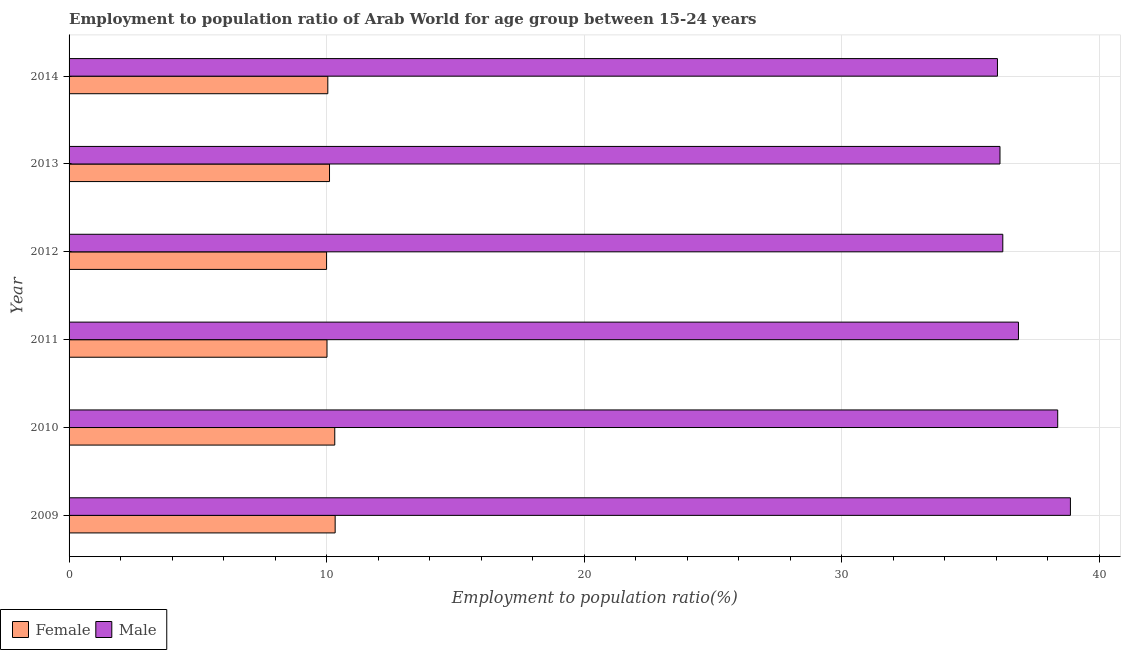How many groups of bars are there?
Provide a short and direct response. 6. Are the number of bars per tick equal to the number of legend labels?
Offer a very short reply. Yes. How many bars are there on the 4th tick from the top?
Your answer should be very brief. 2. How many bars are there on the 4th tick from the bottom?
Provide a succinct answer. 2. What is the label of the 1st group of bars from the top?
Offer a terse response. 2014. What is the employment to population ratio(female) in 2013?
Ensure brevity in your answer.  10.11. Across all years, what is the maximum employment to population ratio(female)?
Make the answer very short. 10.33. Across all years, what is the minimum employment to population ratio(female)?
Ensure brevity in your answer.  10. In which year was the employment to population ratio(female) maximum?
Keep it short and to the point. 2009. What is the total employment to population ratio(female) in the graph?
Keep it short and to the point. 60.83. What is the difference between the employment to population ratio(female) in 2012 and that in 2013?
Your response must be concise. -0.11. What is the difference between the employment to population ratio(female) in 2009 and the employment to population ratio(male) in 2012?
Provide a short and direct response. -25.93. What is the average employment to population ratio(male) per year?
Offer a terse response. 37.1. In the year 2011, what is the difference between the employment to population ratio(female) and employment to population ratio(male)?
Offer a very short reply. -26.85. Is the employment to population ratio(female) in 2011 less than that in 2012?
Provide a succinct answer. No. Is the difference between the employment to population ratio(female) in 2010 and 2011 greater than the difference between the employment to population ratio(male) in 2010 and 2011?
Offer a terse response. No. What is the difference between the highest and the second highest employment to population ratio(male)?
Make the answer very short. 0.49. What is the difference between the highest and the lowest employment to population ratio(male)?
Offer a very short reply. 2.83. In how many years, is the employment to population ratio(female) greater than the average employment to population ratio(female) taken over all years?
Offer a very short reply. 2. Is the sum of the employment to population ratio(female) in 2009 and 2014 greater than the maximum employment to population ratio(male) across all years?
Your response must be concise. No. What does the 1st bar from the top in 2014 represents?
Provide a short and direct response. Male. What does the 2nd bar from the bottom in 2010 represents?
Offer a terse response. Male. Are all the bars in the graph horizontal?
Keep it short and to the point. Yes. How many years are there in the graph?
Offer a terse response. 6. What is the difference between two consecutive major ticks on the X-axis?
Provide a short and direct response. 10. Are the values on the major ticks of X-axis written in scientific E-notation?
Give a very brief answer. No. Does the graph contain grids?
Your answer should be very brief. Yes. How are the legend labels stacked?
Make the answer very short. Horizontal. What is the title of the graph?
Offer a very short reply. Employment to population ratio of Arab World for age group between 15-24 years. Does "Rural Population" appear as one of the legend labels in the graph?
Ensure brevity in your answer.  No. What is the Employment to population ratio(%) in Female in 2009?
Your answer should be compact. 10.33. What is the Employment to population ratio(%) of Male in 2009?
Your answer should be very brief. 38.89. What is the Employment to population ratio(%) of Female in 2010?
Give a very brief answer. 10.32. What is the Employment to population ratio(%) in Male in 2010?
Your answer should be very brief. 38.39. What is the Employment to population ratio(%) of Female in 2011?
Provide a succinct answer. 10.02. What is the Employment to population ratio(%) in Male in 2011?
Ensure brevity in your answer.  36.87. What is the Employment to population ratio(%) in Female in 2012?
Provide a short and direct response. 10. What is the Employment to population ratio(%) in Male in 2012?
Your answer should be compact. 36.26. What is the Employment to population ratio(%) in Female in 2013?
Provide a short and direct response. 10.11. What is the Employment to population ratio(%) in Male in 2013?
Provide a succinct answer. 36.15. What is the Employment to population ratio(%) in Female in 2014?
Provide a succinct answer. 10.05. What is the Employment to population ratio(%) in Male in 2014?
Make the answer very short. 36.05. Across all years, what is the maximum Employment to population ratio(%) of Female?
Provide a succinct answer. 10.33. Across all years, what is the maximum Employment to population ratio(%) in Male?
Offer a terse response. 38.89. Across all years, what is the minimum Employment to population ratio(%) of Female?
Make the answer very short. 10. Across all years, what is the minimum Employment to population ratio(%) of Male?
Keep it short and to the point. 36.05. What is the total Employment to population ratio(%) in Female in the graph?
Your answer should be very brief. 60.83. What is the total Employment to population ratio(%) in Male in the graph?
Offer a terse response. 222.62. What is the difference between the Employment to population ratio(%) in Female in 2009 and that in 2010?
Offer a very short reply. 0.02. What is the difference between the Employment to population ratio(%) of Male in 2009 and that in 2010?
Your answer should be very brief. 0.49. What is the difference between the Employment to population ratio(%) in Female in 2009 and that in 2011?
Your answer should be compact. 0.32. What is the difference between the Employment to population ratio(%) in Male in 2009 and that in 2011?
Your response must be concise. 2.02. What is the difference between the Employment to population ratio(%) in Female in 2009 and that in 2012?
Offer a very short reply. 0.33. What is the difference between the Employment to population ratio(%) of Male in 2009 and that in 2012?
Ensure brevity in your answer.  2.63. What is the difference between the Employment to population ratio(%) in Female in 2009 and that in 2013?
Ensure brevity in your answer.  0.22. What is the difference between the Employment to population ratio(%) of Male in 2009 and that in 2013?
Your response must be concise. 2.74. What is the difference between the Employment to population ratio(%) of Female in 2009 and that in 2014?
Make the answer very short. 0.29. What is the difference between the Employment to population ratio(%) in Male in 2009 and that in 2014?
Offer a terse response. 2.83. What is the difference between the Employment to population ratio(%) of Female in 2010 and that in 2011?
Give a very brief answer. 0.3. What is the difference between the Employment to population ratio(%) in Male in 2010 and that in 2011?
Ensure brevity in your answer.  1.52. What is the difference between the Employment to population ratio(%) in Female in 2010 and that in 2012?
Your answer should be compact. 0.32. What is the difference between the Employment to population ratio(%) in Male in 2010 and that in 2012?
Give a very brief answer. 2.13. What is the difference between the Employment to population ratio(%) of Female in 2010 and that in 2013?
Offer a very short reply. 0.2. What is the difference between the Employment to population ratio(%) in Male in 2010 and that in 2013?
Ensure brevity in your answer.  2.24. What is the difference between the Employment to population ratio(%) of Female in 2010 and that in 2014?
Make the answer very short. 0.27. What is the difference between the Employment to population ratio(%) of Male in 2010 and that in 2014?
Your answer should be very brief. 2.34. What is the difference between the Employment to population ratio(%) of Female in 2011 and that in 2012?
Your answer should be compact. 0.02. What is the difference between the Employment to population ratio(%) in Male in 2011 and that in 2012?
Keep it short and to the point. 0.61. What is the difference between the Employment to population ratio(%) of Female in 2011 and that in 2013?
Give a very brief answer. -0.1. What is the difference between the Employment to population ratio(%) in Male in 2011 and that in 2013?
Offer a very short reply. 0.72. What is the difference between the Employment to population ratio(%) in Female in 2011 and that in 2014?
Your response must be concise. -0.03. What is the difference between the Employment to population ratio(%) of Male in 2011 and that in 2014?
Ensure brevity in your answer.  0.82. What is the difference between the Employment to population ratio(%) in Female in 2012 and that in 2013?
Make the answer very short. -0.11. What is the difference between the Employment to population ratio(%) in Male in 2012 and that in 2013?
Keep it short and to the point. 0.11. What is the difference between the Employment to population ratio(%) of Female in 2012 and that in 2014?
Give a very brief answer. -0.05. What is the difference between the Employment to population ratio(%) of Male in 2012 and that in 2014?
Your answer should be compact. 0.21. What is the difference between the Employment to population ratio(%) in Female in 2013 and that in 2014?
Keep it short and to the point. 0.07. What is the difference between the Employment to population ratio(%) in Male in 2013 and that in 2014?
Offer a terse response. 0.1. What is the difference between the Employment to population ratio(%) of Female in 2009 and the Employment to population ratio(%) of Male in 2010?
Provide a short and direct response. -28.06. What is the difference between the Employment to population ratio(%) of Female in 2009 and the Employment to population ratio(%) of Male in 2011?
Your answer should be compact. -26.54. What is the difference between the Employment to population ratio(%) in Female in 2009 and the Employment to population ratio(%) in Male in 2012?
Your answer should be very brief. -25.93. What is the difference between the Employment to population ratio(%) of Female in 2009 and the Employment to population ratio(%) of Male in 2013?
Keep it short and to the point. -25.82. What is the difference between the Employment to population ratio(%) of Female in 2009 and the Employment to population ratio(%) of Male in 2014?
Make the answer very short. -25.72. What is the difference between the Employment to population ratio(%) in Female in 2010 and the Employment to population ratio(%) in Male in 2011?
Your response must be concise. -26.55. What is the difference between the Employment to population ratio(%) in Female in 2010 and the Employment to population ratio(%) in Male in 2012?
Your answer should be compact. -25.94. What is the difference between the Employment to population ratio(%) in Female in 2010 and the Employment to population ratio(%) in Male in 2013?
Your answer should be very brief. -25.83. What is the difference between the Employment to population ratio(%) in Female in 2010 and the Employment to population ratio(%) in Male in 2014?
Your answer should be very brief. -25.74. What is the difference between the Employment to population ratio(%) of Female in 2011 and the Employment to population ratio(%) of Male in 2012?
Your answer should be very brief. -26.24. What is the difference between the Employment to population ratio(%) in Female in 2011 and the Employment to population ratio(%) in Male in 2013?
Provide a succinct answer. -26.14. What is the difference between the Employment to population ratio(%) in Female in 2011 and the Employment to population ratio(%) in Male in 2014?
Offer a terse response. -26.04. What is the difference between the Employment to population ratio(%) of Female in 2012 and the Employment to population ratio(%) of Male in 2013?
Your answer should be compact. -26.15. What is the difference between the Employment to population ratio(%) of Female in 2012 and the Employment to population ratio(%) of Male in 2014?
Offer a terse response. -26.05. What is the difference between the Employment to population ratio(%) in Female in 2013 and the Employment to population ratio(%) in Male in 2014?
Provide a succinct answer. -25.94. What is the average Employment to population ratio(%) in Female per year?
Offer a very short reply. 10.14. What is the average Employment to population ratio(%) in Male per year?
Your answer should be very brief. 37.1. In the year 2009, what is the difference between the Employment to population ratio(%) in Female and Employment to population ratio(%) in Male?
Offer a very short reply. -28.55. In the year 2010, what is the difference between the Employment to population ratio(%) in Female and Employment to population ratio(%) in Male?
Your answer should be compact. -28.08. In the year 2011, what is the difference between the Employment to population ratio(%) of Female and Employment to population ratio(%) of Male?
Your answer should be very brief. -26.85. In the year 2012, what is the difference between the Employment to population ratio(%) in Female and Employment to population ratio(%) in Male?
Provide a short and direct response. -26.26. In the year 2013, what is the difference between the Employment to population ratio(%) of Female and Employment to population ratio(%) of Male?
Your answer should be compact. -26.04. In the year 2014, what is the difference between the Employment to population ratio(%) of Female and Employment to population ratio(%) of Male?
Make the answer very short. -26.01. What is the ratio of the Employment to population ratio(%) of Female in 2009 to that in 2010?
Your answer should be compact. 1. What is the ratio of the Employment to population ratio(%) of Male in 2009 to that in 2010?
Your response must be concise. 1.01. What is the ratio of the Employment to population ratio(%) of Female in 2009 to that in 2011?
Offer a very short reply. 1.03. What is the ratio of the Employment to population ratio(%) in Male in 2009 to that in 2011?
Give a very brief answer. 1.05. What is the ratio of the Employment to population ratio(%) in Male in 2009 to that in 2012?
Provide a succinct answer. 1.07. What is the ratio of the Employment to population ratio(%) in Female in 2009 to that in 2013?
Your answer should be compact. 1.02. What is the ratio of the Employment to population ratio(%) in Male in 2009 to that in 2013?
Offer a very short reply. 1.08. What is the ratio of the Employment to population ratio(%) of Female in 2009 to that in 2014?
Provide a short and direct response. 1.03. What is the ratio of the Employment to population ratio(%) of Male in 2009 to that in 2014?
Offer a terse response. 1.08. What is the ratio of the Employment to population ratio(%) of Female in 2010 to that in 2011?
Your response must be concise. 1.03. What is the ratio of the Employment to population ratio(%) of Male in 2010 to that in 2011?
Offer a very short reply. 1.04. What is the ratio of the Employment to population ratio(%) in Female in 2010 to that in 2012?
Provide a succinct answer. 1.03. What is the ratio of the Employment to population ratio(%) of Male in 2010 to that in 2012?
Provide a succinct answer. 1.06. What is the ratio of the Employment to population ratio(%) of Female in 2010 to that in 2013?
Give a very brief answer. 1.02. What is the ratio of the Employment to population ratio(%) of Male in 2010 to that in 2013?
Offer a very short reply. 1.06. What is the ratio of the Employment to population ratio(%) of Female in 2010 to that in 2014?
Make the answer very short. 1.03. What is the ratio of the Employment to population ratio(%) of Male in 2010 to that in 2014?
Make the answer very short. 1.06. What is the ratio of the Employment to population ratio(%) of Male in 2011 to that in 2012?
Your answer should be compact. 1.02. What is the ratio of the Employment to population ratio(%) in Female in 2011 to that in 2013?
Give a very brief answer. 0.99. What is the ratio of the Employment to population ratio(%) in Male in 2011 to that in 2013?
Keep it short and to the point. 1.02. What is the ratio of the Employment to population ratio(%) of Female in 2011 to that in 2014?
Keep it short and to the point. 1. What is the ratio of the Employment to population ratio(%) of Male in 2011 to that in 2014?
Provide a succinct answer. 1.02. What is the ratio of the Employment to population ratio(%) of Female in 2012 to that in 2013?
Ensure brevity in your answer.  0.99. What is the ratio of the Employment to population ratio(%) of Female in 2013 to that in 2014?
Your answer should be very brief. 1.01. What is the ratio of the Employment to population ratio(%) of Male in 2013 to that in 2014?
Ensure brevity in your answer.  1. What is the difference between the highest and the second highest Employment to population ratio(%) of Female?
Offer a very short reply. 0.02. What is the difference between the highest and the second highest Employment to population ratio(%) in Male?
Make the answer very short. 0.49. What is the difference between the highest and the lowest Employment to population ratio(%) of Female?
Provide a short and direct response. 0.33. What is the difference between the highest and the lowest Employment to population ratio(%) in Male?
Give a very brief answer. 2.83. 